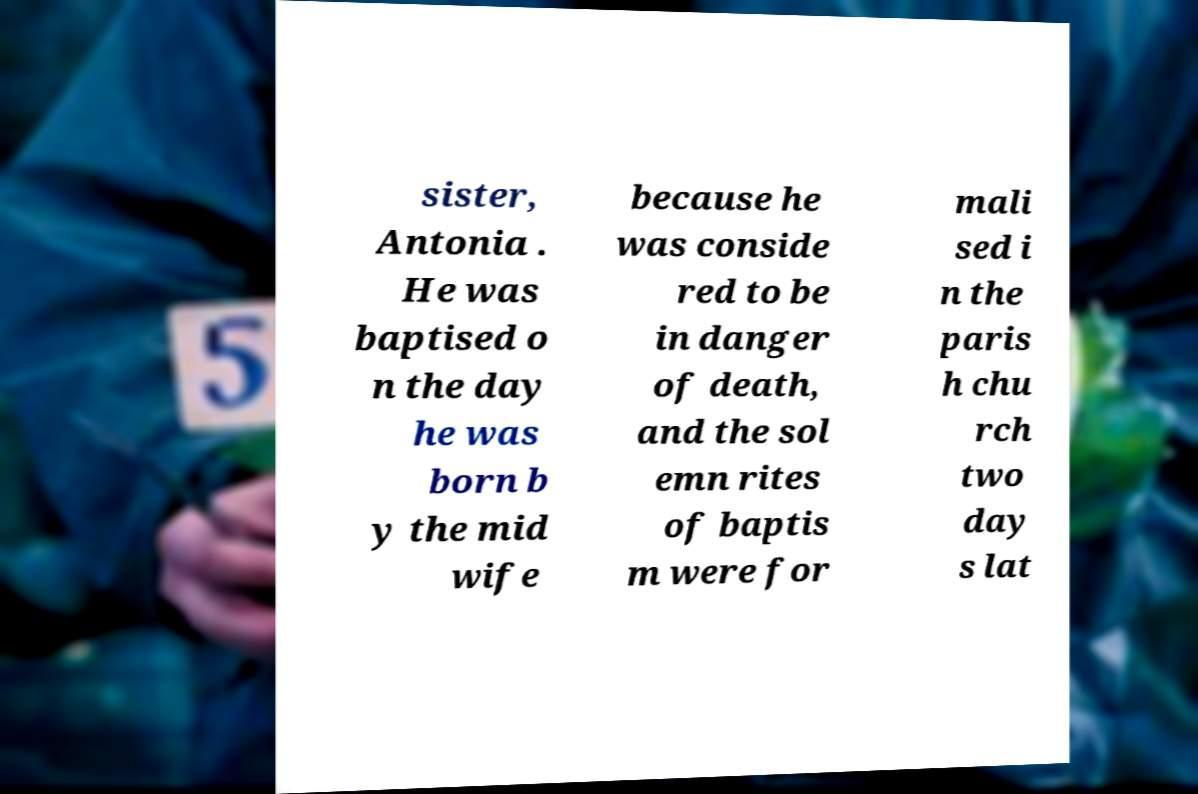Please identify and transcribe the text found in this image. sister, Antonia . He was baptised o n the day he was born b y the mid wife because he was conside red to be in danger of death, and the sol emn rites of baptis m were for mali sed i n the paris h chu rch two day s lat 